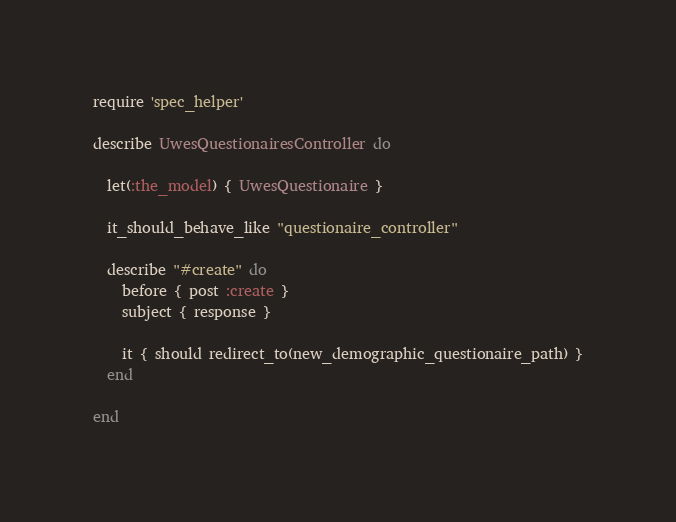<code> <loc_0><loc_0><loc_500><loc_500><_Ruby_>require 'spec_helper'

describe UwesQuestionairesController do

  let(:the_model) { UwesQuestionaire }

  it_should_behave_like "questionaire_controller"

  describe "#create" do
    before { post :create }
    subject { response }

    it { should redirect_to(new_demographic_questionaire_path) }
  end

end
</code> 